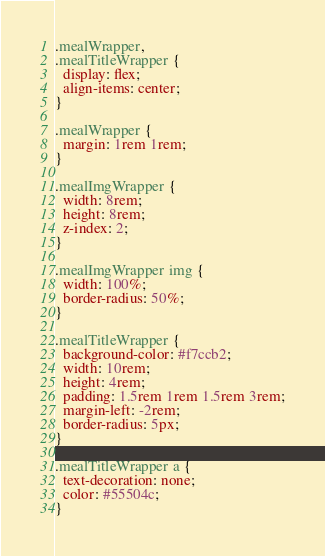<code> <loc_0><loc_0><loc_500><loc_500><_CSS_>.mealWrapper,
.mealTitleWrapper {
  display: flex;
  align-items: center;
}

.mealWrapper {
  margin: 1rem 1rem;
}

.mealImgWrapper {
  width: 8rem;
  height: 8rem;
  z-index: 2;
}

.mealImgWrapper img {
  width: 100%;
  border-radius: 50%;
}

.mealTitleWrapper {
  background-color: #f7ccb2;
  width: 10rem;
  height: 4rem;
  padding: 1.5rem 1rem 1.5rem 3rem;
  margin-left: -2rem;
  border-radius: 5px;
}

.mealTitleWrapper a {
  text-decoration: none;
  color: #55504c;
}
</code> 